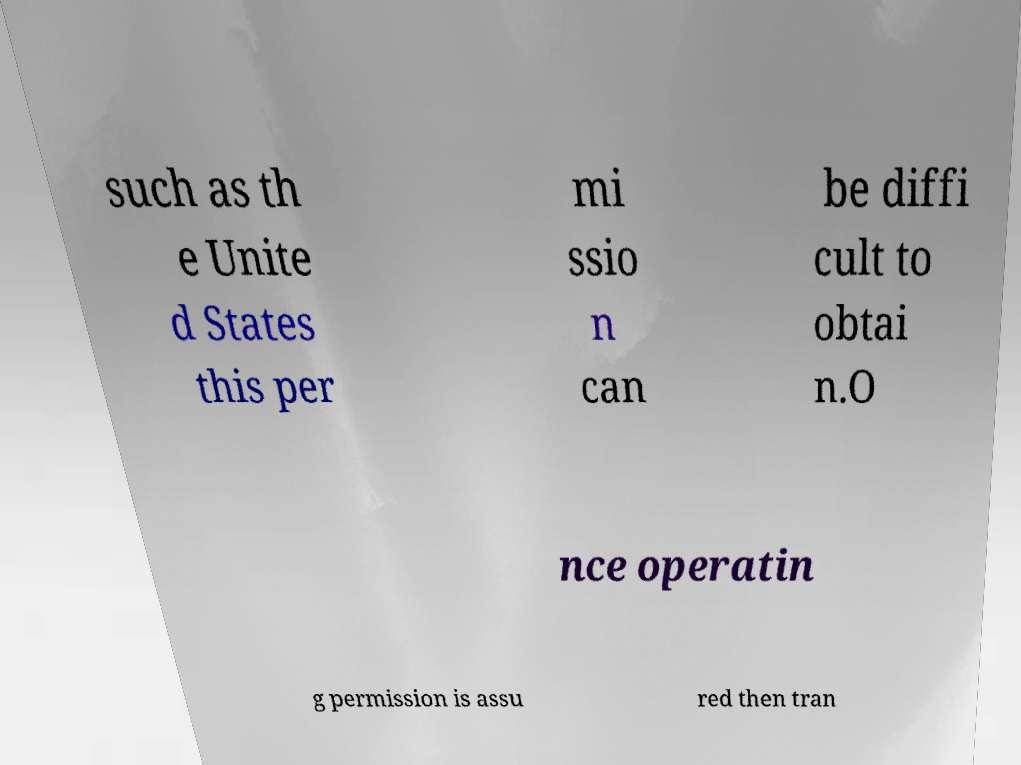What messages or text are displayed in this image? I need them in a readable, typed format. such as th e Unite d States this per mi ssio n can be diffi cult to obtai n.O nce operatin g permission is assu red then tran 